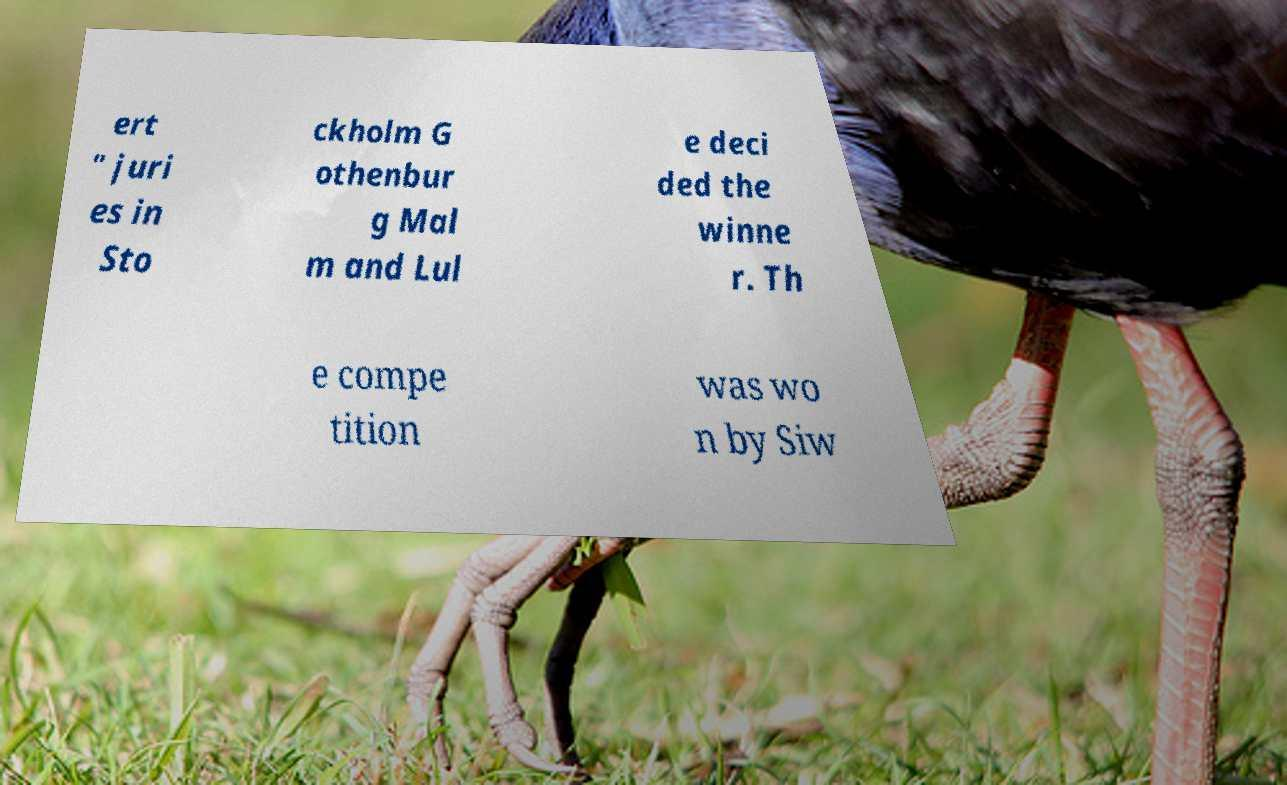Can you read and provide the text displayed in the image?This photo seems to have some interesting text. Can you extract and type it out for me? ert " juri es in Sto ckholm G othenbur g Mal m and Lul e deci ded the winne r. Th e compe tition was wo n by Siw 